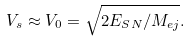Convert formula to latex. <formula><loc_0><loc_0><loc_500><loc_500>V _ { s } \approx V _ { 0 } = \sqrt { 2 E _ { S N } / M _ { e j } } .</formula> 